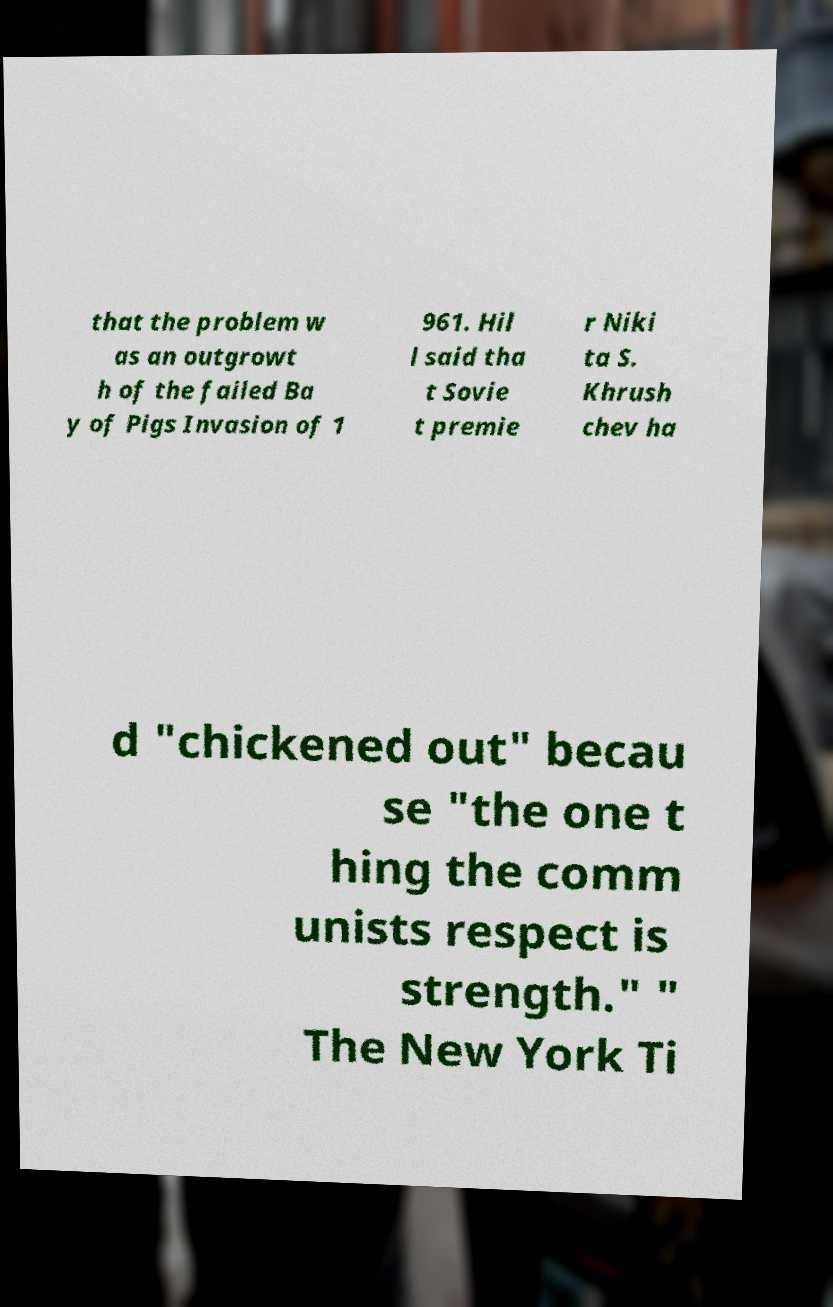There's text embedded in this image that I need extracted. Can you transcribe it verbatim? that the problem w as an outgrowt h of the failed Ba y of Pigs Invasion of 1 961. Hil l said tha t Sovie t premie r Niki ta S. Khrush chev ha d "chickened out" becau se "the one t hing the comm unists respect is strength." " The New York Ti 